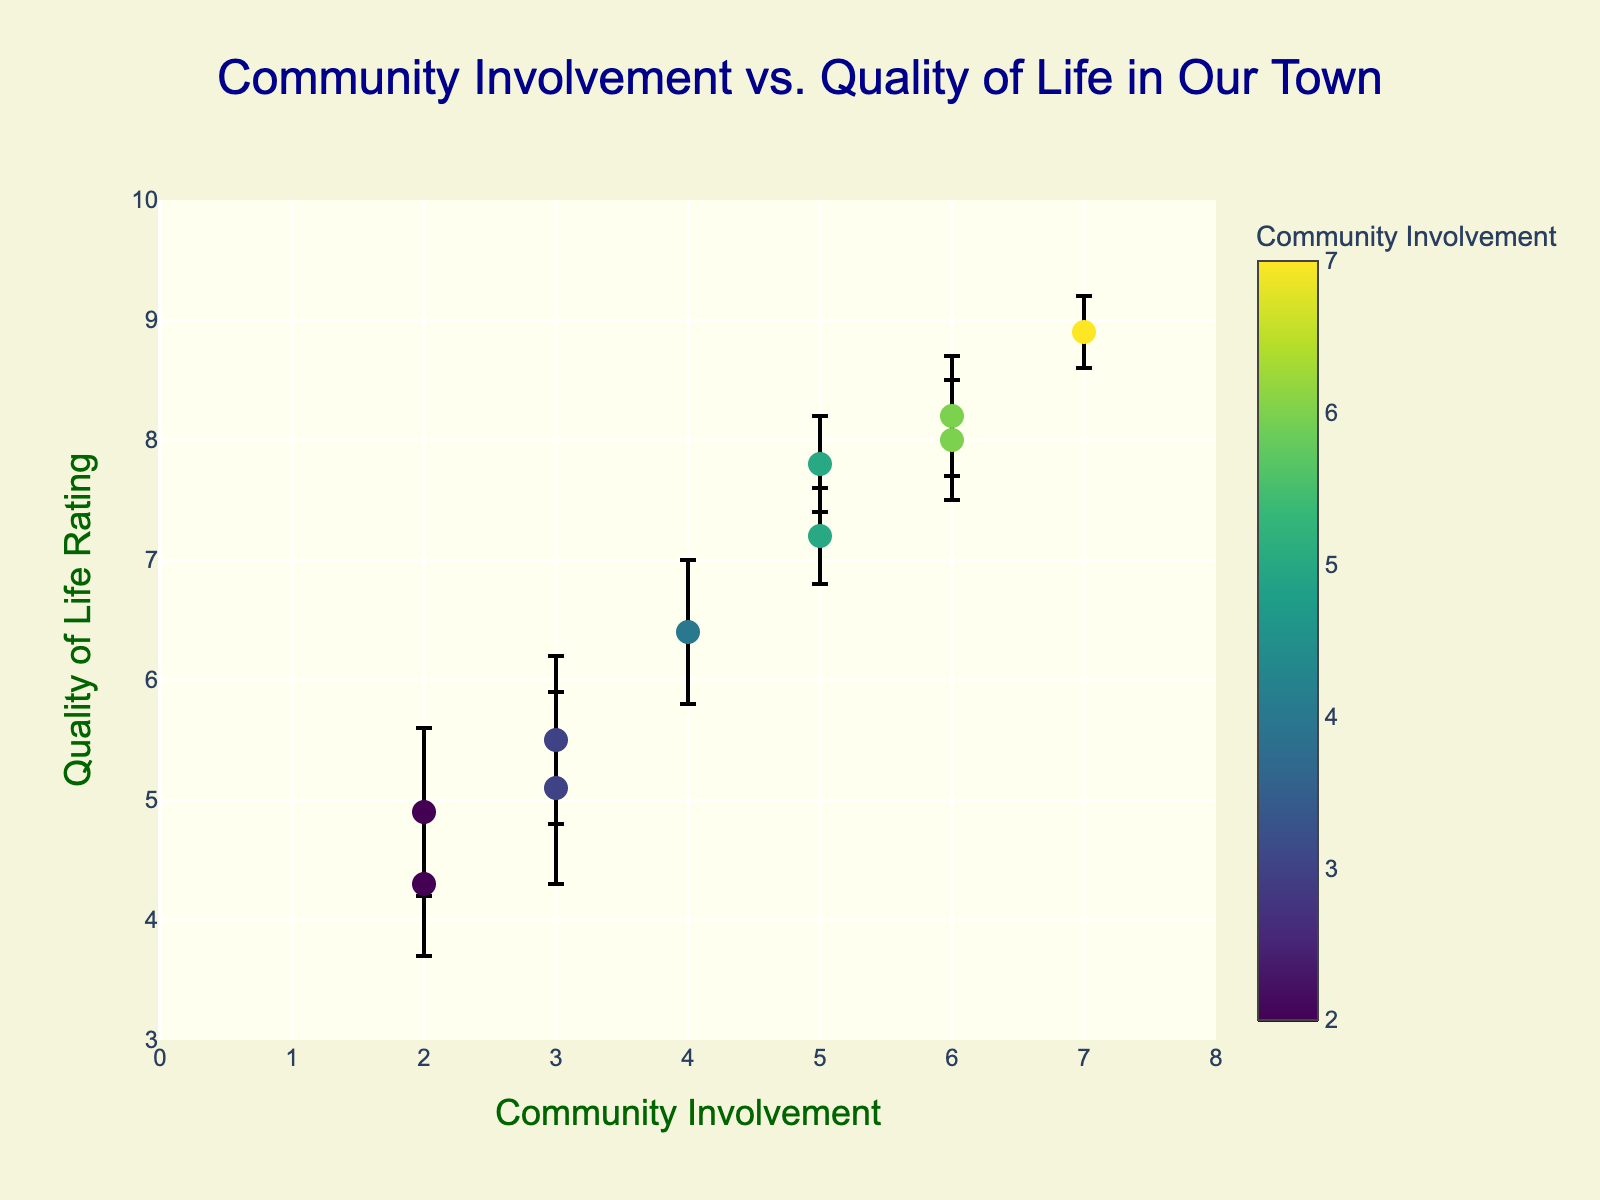What is the title of the figure? The title is typically located at the top of the plot and summarizes the main subject of the data presented.
Answer: Community Involvement vs. Quality of Life in Our Town How many data points are there in the plot? Count the number of markers (dots) in the scatter plot to find the number of data points.
Answer: 10 What range of Community Involvement values is displayed on the x-axis? Look at the minimum and maximum values on the x-axis to determine the range.
Answer: 0 to 8 What is the Quality of Life rating for a Community Involvement value of 7? Locate the marker on the x-axis at 7 and check its corresponding y-axis value.
Answer: 8.9 Which data point has the highest Quality of Life rating and what is that rating? Identify the marker at the highest y-axis position and note its y-axis value.
Answer: 8.9 What is the average Quality of Life rating for Community Involvement values of 2? Locate the markers with x-axis value 2, sum their y-values, and divide by the number of markers. (4.3 + 4.9) / 2 = 4.6
Answer: 4.6 What is the difference in Quality of Life ratings between Community Involvement levels 3 and 5? Find the average Quality of Life ratings for Community Involvement levels 3 and 5, then subtract the smaller from the larger. [(5.5 + 5.1)/2] - [(7.8 + 7.2)/2] = 5.3 - 7.5 = -2.2
Answer: -2.2 Which data point has the largest error bar, and what is the size of that error bar? Compare the lengths of the error bars for each marker; the largest one will have the highest value.
Answer: The data point with Community Involvement 3 and Quality of Life 5.1 has an error bar of 0.8 Is there a positive correlation between Community Involvement and Quality of Life ratings? Observe the general trend of the markers as they move from left to right. If they tend to ascend, there is a positive correlation.
Answer: Yes How does the variability in perception (error bars) compare for higher vs. lower Community Involvement values? Compare the lengths of error bars at higher x-axis values (right side) with those at lower x-axis values (left side).
Answer: Variability is generally lower for higher Community Involvement values 